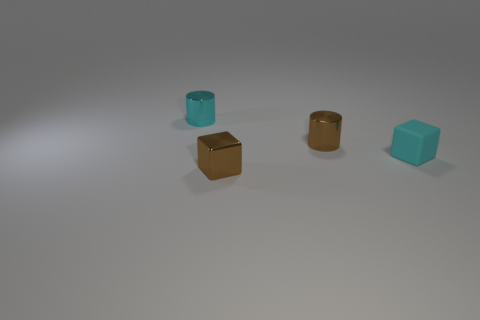Is there a big green shiny thing that has the same shape as the cyan shiny thing?
Your answer should be very brief. No. Is the shape of the brown thing right of the brown metallic cube the same as the tiny thing that is behind the tiny brown cylinder?
Keep it short and to the point. Yes. Is there a cyan metal cylinder of the same size as the brown metal block?
Keep it short and to the point. Yes. Are there an equal number of brown shiny things that are behind the cyan metallic object and small brown cubes that are on the right side of the tiny cyan rubber block?
Ensure brevity in your answer.  Yes. Does the tiny cyan thing that is on the left side of the tiny cyan rubber object have the same material as the tiny block that is on the left side of the matte thing?
Make the answer very short. Yes. What material is the cyan cube?
Offer a very short reply. Rubber. What number of other things are there of the same color as the tiny matte object?
Provide a short and direct response. 1. Is the color of the metallic cube the same as the rubber thing?
Provide a succinct answer. No. What number of small cyan objects are there?
Your answer should be very brief. 2. There is a tiny cyan thing behind the small brown shiny thing that is on the right side of the metallic block; what is it made of?
Make the answer very short. Metal. 